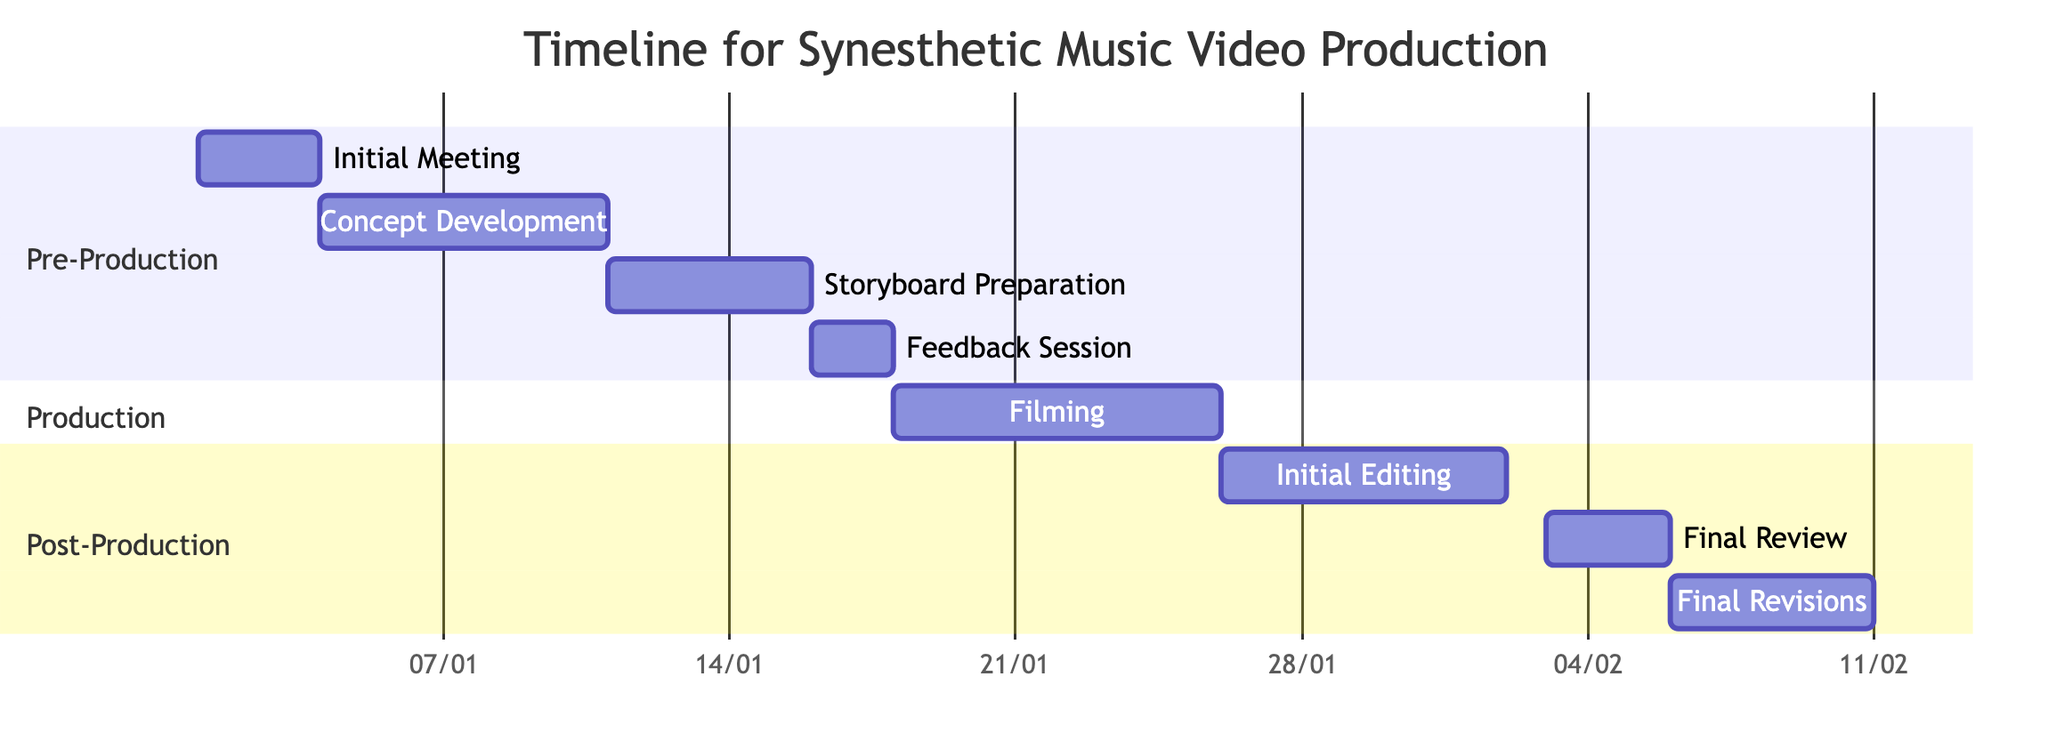What is the duration of the "Filming" task? The "Filming" task spans from January 18, 2024, to January 25, 2024, which is 8 days in total.
Answer: 8 days What two tasks have the same starting date? Both "Initial Editing" and "Final Review" tasks begin on January 26, 2024.
Answer: Initial Editing and Final Review How many days are allocated for the "Final Revisions" task? The "Final Revisions" task lasts for 5 days, starting from February 6, 2024, to February 10, 2024.
Answer: 5 days Which task immediately follows the "Feedback Session"? The "Filming" task immediately follows the "Feedback Session," starting on January 18, 2024.
Answer: Filming What section does the "Initial Meeting" belong to? The "Initial Meeting" is categorized under the "Pre-Production" section of the project timeline.
Answer: Pre-Production How many total tasks are included in the Gantt chart? There are a total of 8 tasks listed in the Gantt chart.
Answer: 8 tasks What is the total duration from the start of the "Initial Meeting" to the end of the "Final Revisions"? The project timeline starts on January 1, 2024, and concludes on February 10, 2024, giving it a total duration of 40 days.
Answer: 40 days What is the task following the "Storyboard Preparation"? The task that follows "Storyboard Preparation" is the "Feedback Session," starting on January 16, 2024.
Answer: Feedback Session Which task has the shortest duration? The "Feedback Session" has the shortest duration of 2 days.
Answer: 2 days 